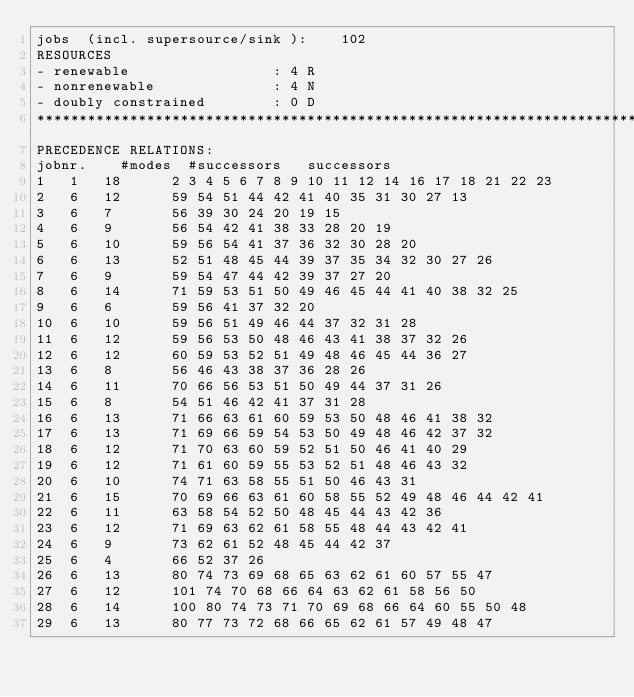Convert code to text. <code><loc_0><loc_0><loc_500><loc_500><_ObjectiveC_>jobs  (incl. supersource/sink ):	102
RESOURCES
- renewable                 : 4 R
- nonrenewable              : 4 N
- doubly constrained        : 0 D
************************************************************************
PRECEDENCE RELATIONS:
jobnr.    #modes  #successors   successors
1	1	18		2 3 4 5 6 7 8 9 10 11 12 14 16 17 18 21 22 23 
2	6	12		59 54 51 44 42 41 40 35 31 30 27 13 
3	6	7		56 39 30 24 20 19 15 
4	6	9		56 54 42 41 38 33 28 20 19 
5	6	10		59 56 54 41 37 36 32 30 28 20 
6	6	13		52 51 48 45 44 39 37 35 34 32 30 27 26 
7	6	9		59 54 47 44 42 39 37 27 20 
8	6	14		71 59 53 51 50 49 46 45 44 41 40 38 32 25 
9	6	6		59 56 41 37 32 20 
10	6	10		59 56 51 49 46 44 37 32 31 28 
11	6	12		59 56 53 50 48 46 43 41 38 37 32 26 
12	6	12		60 59 53 52 51 49 48 46 45 44 36 27 
13	6	8		56 46 43 38 37 36 28 26 
14	6	11		70 66 56 53 51 50 49 44 37 31 26 
15	6	8		54 51 46 42 41 37 31 28 
16	6	13		71 66 63 61 60 59 53 50 48 46 41 38 32 
17	6	13		71 69 66 59 54 53 50 49 48 46 42 37 32 
18	6	12		71 70 63 60 59 52 51 50 46 41 40 29 
19	6	12		71 61 60 59 55 53 52 51 48 46 43 32 
20	6	10		74 71 63 58 55 51 50 46 43 31 
21	6	15		70 69 66 63 61 60 58 55 52 49 48 46 44 42 41 
22	6	11		63 58 54 52 50 48 45 44 43 42 36 
23	6	12		71 69 63 62 61 58 55 48 44 43 42 41 
24	6	9		73 62 61 52 48 45 44 42 37 
25	6	4		66 52 37 26 
26	6	13		80 74 73 69 68 65 63 62 61 60 57 55 47 
27	6	12		101 74 70 68 66 64 63 62 61 58 56 50 
28	6	14		100 80 74 73 71 70 69 68 66 64 60 55 50 48 
29	6	13		80 77 73 72 68 66 65 62 61 57 49 48 47 </code> 